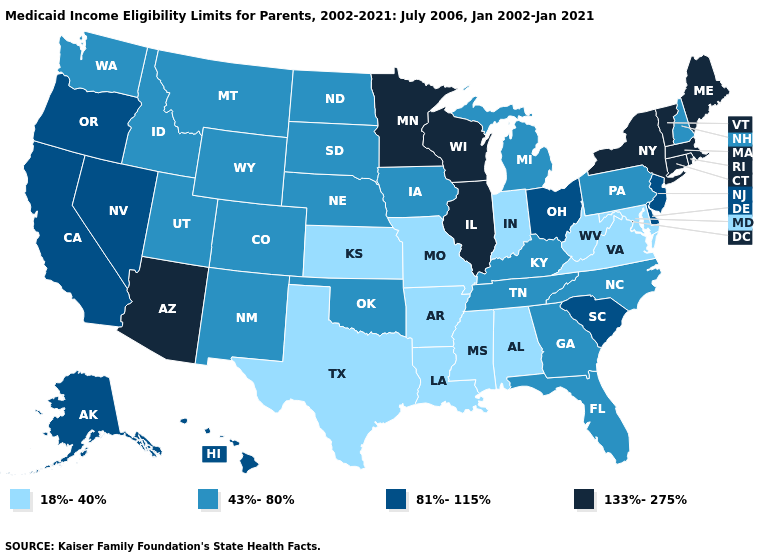Name the states that have a value in the range 81%-115%?
Answer briefly. Alaska, California, Delaware, Hawaii, Nevada, New Jersey, Ohio, Oregon, South Carolina. Does Maine have a higher value than Arizona?
Keep it brief. No. What is the value of Ohio?
Keep it brief. 81%-115%. What is the value of Washington?
Be succinct. 43%-80%. Does Connecticut have the highest value in the Northeast?
Answer briefly. Yes. What is the value of Nevada?
Short answer required. 81%-115%. Which states have the highest value in the USA?
Give a very brief answer. Arizona, Connecticut, Illinois, Maine, Massachusetts, Minnesota, New York, Rhode Island, Vermont, Wisconsin. Which states have the lowest value in the USA?
Answer briefly. Alabama, Arkansas, Indiana, Kansas, Louisiana, Maryland, Mississippi, Missouri, Texas, Virginia, West Virginia. Does New York have the highest value in the USA?
Short answer required. Yes. Does Arizona have the same value as Minnesota?
Concise answer only. Yes. What is the lowest value in the MidWest?
Be succinct. 18%-40%. Name the states that have a value in the range 133%-275%?
Short answer required. Arizona, Connecticut, Illinois, Maine, Massachusetts, Minnesota, New York, Rhode Island, Vermont, Wisconsin. Is the legend a continuous bar?
Give a very brief answer. No. What is the value of South Carolina?
Answer briefly. 81%-115%. What is the value of Maine?
Be succinct. 133%-275%. 